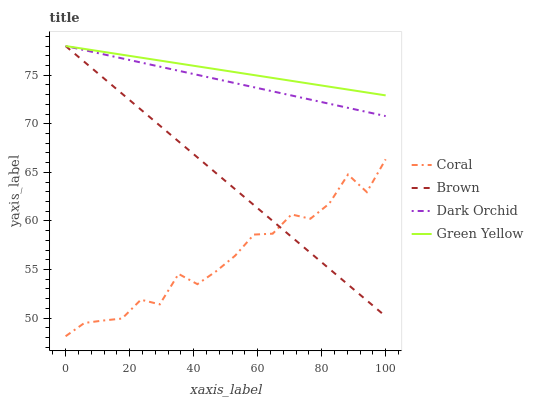Does Coral have the minimum area under the curve?
Answer yes or no. Yes. Does Green Yellow have the maximum area under the curve?
Answer yes or no. Yes. Does Green Yellow have the minimum area under the curve?
Answer yes or no. No. Does Coral have the maximum area under the curve?
Answer yes or no. No. Is Dark Orchid the smoothest?
Answer yes or no. Yes. Is Coral the roughest?
Answer yes or no. Yes. Is Green Yellow the smoothest?
Answer yes or no. No. Is Green Yellow the roughest?
Answer yes or no. No. Does Coral have the lowest value?
Answer yes or no. Yes. Does Green Yellow have the lowest value?
Answer yes or no. No. Does Dark Orchid have the highest value?
Answer yes or no. Yes. Does Coral have the highest value?
Answer yes or no. No. Is Coral less than Green Yellow?
Answer yes or no. Yes. Is Green Yellow greater than Coral?
Answer yes or no. Yes. Does Green Yellow intersect Dark Orchid?
Answer yes or no. Yes. Is Green Yellow less than Dark Orchid?
Answer yes or no. No. Is Green Yellow greater than Dark Orchid?
Answer yes or no. No. Does Coral intersect Green Yellow?
Answer yes or no. No. 